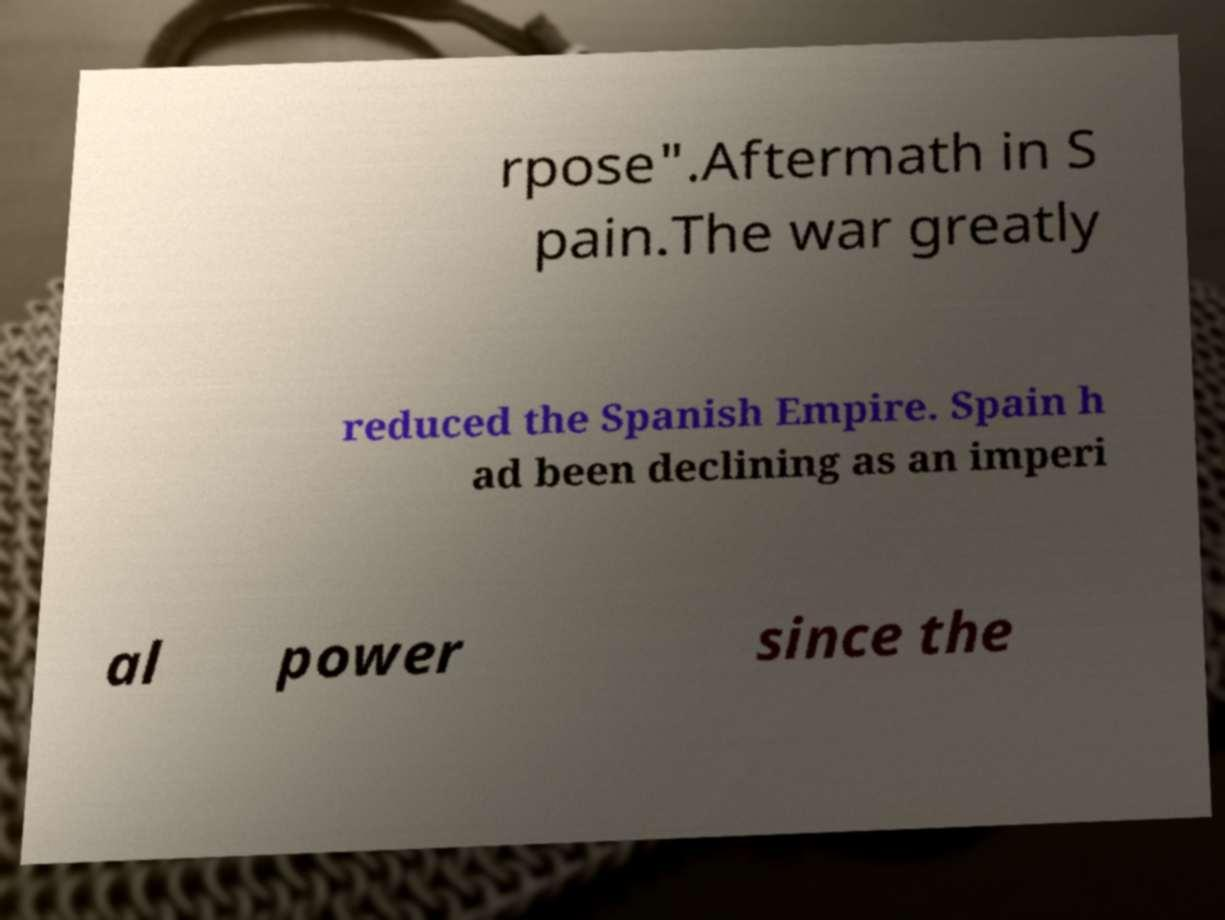Could you assist in decoding the text presented in this image and type it out clearly? rpose".Aftermath in S pain.The war greatly reduced the Spanish Empire. Spain h ad been declining as an imperi al power since the 